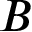Convert formula to latex. <formula><loc_0><loc_0><loc_500><loc_500>B</formula> 